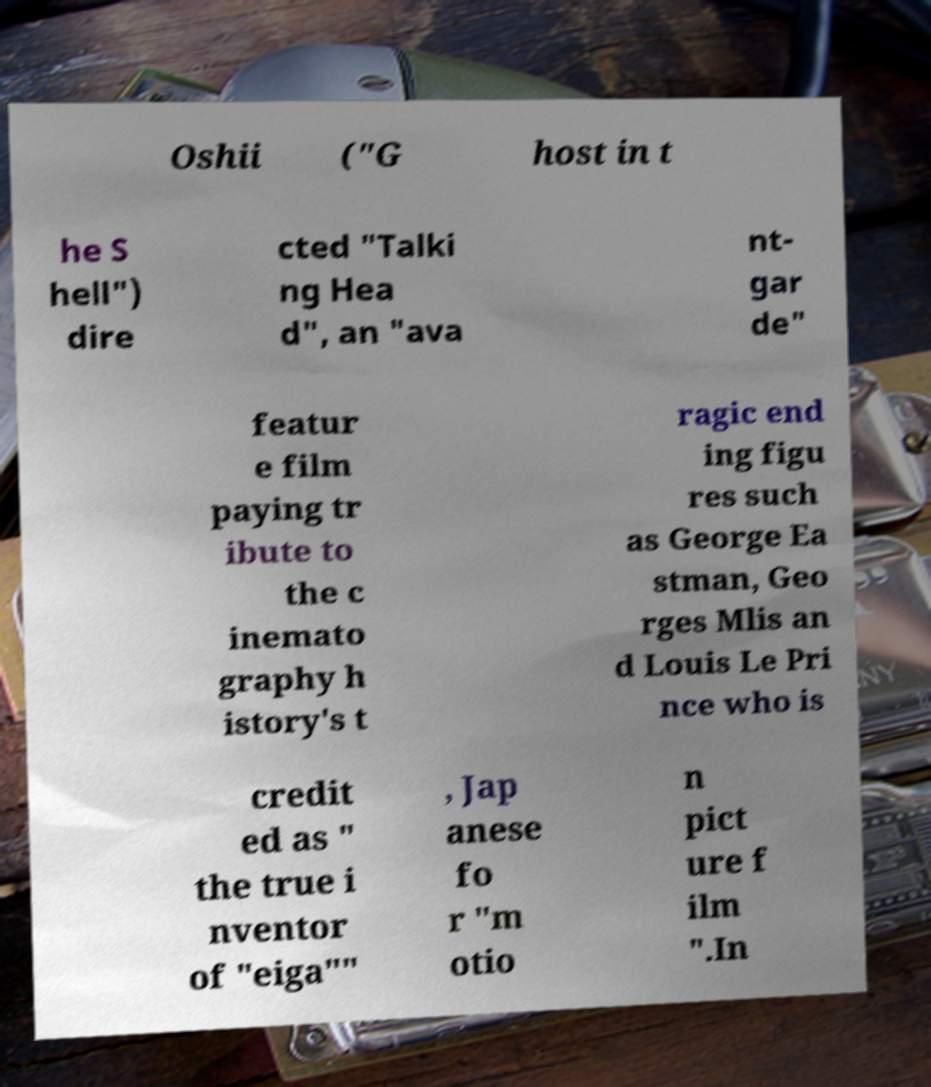Could you extract and type out the text from this image? Oshii ("G host in t he S hell") dire cted "Talki ng Hea d", an "ava nt- gar de" featur e film paying tr ibute to the c inemato graphy h istory's t ragic end ing figu res such as George Ea stman, Geo rges Mlis an d Louis Le Pri nce who is credit ed as " the true i nventor of "eiga"" , Jap anese fo r "m otio n pict ure f ilm ".In 